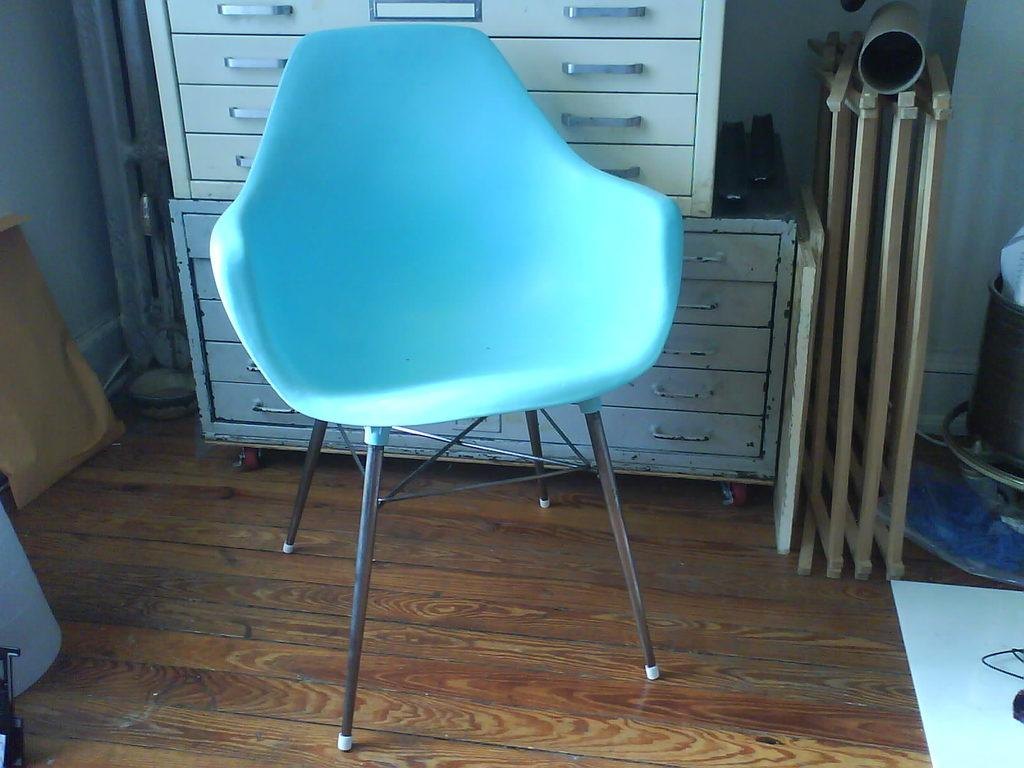What type of furniture can be seen in the background of the image? There is a chair in the background of the image. What type of storage unit is present in the image? There is an iron cupboard in the image. What architectural feature is visible in the image? There is a railing in the image. What type of plumbing fixture is present? There is a pipe in the image. What type of structure is visible in the image? There is a wall in the image. Who is the creator of the trick in the image? There is no trick present in the image, so there is no creator to identify. What type of washing machine is visible in the image? There is no washing machine present in the image. 